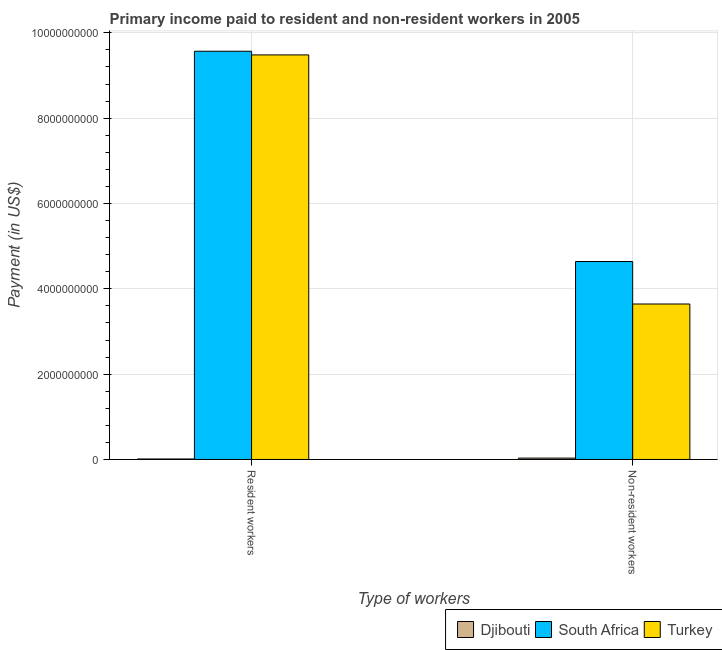How many different coloured bars are there?
Make the answer very short. 3. How many groups of bars are there?
Your answer should be very brief. 2. Are the number of bars per tick equal to the number of legend labels?
Ensure brevity in your answer.  Yes. Are the number of bars on each tick of the X-axis equal?
Make the answer very short. Yes. How many bars are there on the 2nd tick from the right?
Make the answer very short. 3. What is the label of the 1st group of bars from the left?
Offer a very short reply. Resident workers. What is the payment made to non-resident workers in Turkey?
Offer a very short reply. 3.64e+09. Across all countries, what is the maximum payment made to resident workers?
Offer a terse response. 9.57e+09. Across all countries, what is the minimum payment made to non-resident workers?
Ensure brevity in your answer.  3.20e+07. In which country was the payment made to resident workers maximum?
Your answer should be very brief. South Africa. In which country was the payment made to resident workers minimum?
Give a very brief answer. Djibouti. What is the total payment made to non-resident workers in the graph?
Provide a succinct answer. 8.32e+09. What is the difference between the payment made to resident workers in South Africa and that in Turkey?
Make the answer very short. 8.63e+07. What is the difference between the payment made to resident workers in Djibouti and the payment made to non-resident workers in South Africa?
Offer a very short reply. -4.63e+09. What is the average payment made to non-resident workers per country?
Offer a very short reply. 2.77e+09. What is the difference between the payment made to non-resident workers and payment made to resident workers in Djibouti?
Your answer should be compact. 2.08e+07. What is the ratio of the payment made to resident workers in South Africa to that in Djibouti?
Offer a very short reply. 857.19. What does the 2nd bar from the left in Non-resident workers represents?
Offer a terse response. South Africa. What does the 3rd bar from the right in Non-resident workers represents?
Your response must be concise. Djibouti. How many bars are there?
Keep it short and to the point. 6. How many countries are there in the graph?
Offer a terse response. 3. How many legend labels are there?
Your response must be concise. 3. What is the title of the graph?
Ensure brevity in your answer.  Primary income paid to resident and non-resident workers in 2005. Does "American Samoa" appear as one of the legend labels in the graph?
Ensure brevity in your answer.  No. What is the label or title of the X-axis?
Offer a terse response. Type of workers. What is the label or title of the Y-axis?
Keep it short and to the point. Payment (in US$). What is the Payment (in US$) of Djibouti in Resident workers?
Give a very brief answer. 1.12e+07. What is the Payment (in US$) of South Africa in Resident workers?
Offer a terse response. 9.57e+09. What is the Payment (in US$) in Turkey in Resident workers?
Provide a succinct answer. 9.48e+09. What is the Payment (in US$) in Djibouti in Non-resident workers?
Make the answer very short. 3.20e+07. What is the Payment (in US$) of South Africa in Non-resident workers?
Provide a short and direct response. 4.64e+09. What is the Payment (in US$) in Turkey in Non-resident workers?
Offer a terse response. 3.64e+09. Across all Type of workers, what is the maximum Payment (in US$) of Djibouti?
Offer a very short reply. 3.20e+07. Across all Type of workers, what is the maximum Payment (in US$) of South Africa?
Offer a terse response. 9.57e+09. Across all Type of workers, what is the maximum Payment (in US$) of Turkey?
Your response must be concise. 9.48e+09. Across all Type of workers, what is the minimum Payment (in US$) of Djibouti?
Offer a terse response. 1.12e+07. Across all Type of workers, what is the minimum Payment (in US$) in South Africa?
Your answer should be very brief. 4.64e+09. Across all Type of workers, what is the minimum Payment (in US$) in Turkey?
Your answer should be compact. 3.64e+09. What is the total Payment (in US$) of Djibouti in the graph?
Your response must be concise. 4.31e+07. What is the total Payment (in US$) in South Africa in the graph?
Offer a very short reply. 1.42e+1. What is the total Payment (in US$) in Turkey in the graph?
Your answer should be compact. 1.31e+1. What is the difference between the Payment (in US$) of Djibouti in Resident workers and that in Non-resident workers?
Offer a very short reply. -2.08e+07. What is the difference between the Payment (in US$) of South Africa in Resident workers and that in Non-resident workers?
Give a very brief answer. 4.93e+09. What is the difference between the Payment (in US$) of Turkey in Resident workers and that in Non-resident workers?
Ensure brevity in your answer.  5.84e+09. What is the difference between the Payment (in US$) of Djibouti in Resident workers and the Payment (in US$) of South Africa in Non-resident workers?
Keep it short and to the point. -4.63e+09. What is the difference between the Payment (in US$) in Djibouti in Resident workers and the Payment (in US$) in Turkey in Non-resident workers?
Provide a succinct answer. -3.63e+09. What is the difference between the Payment (in US$) in South Africa in Resident workers and the Payment (in US$) in Turkey in Non-resident workers?
Your answer should be compact. 5.93e+09. What is the average Payment (in US$) of Djibouti per Type of workers?
Offer a terse response. 2.16e+07. What is the average Payment (in US$) in South Africa per Type of workers?
Keep it short and to the point. 7.10e+09. What is the average Payment (in US$) of Turkey per Type of workers?
Provide a short and direct response. 6.56e+09. What is the difference between the Payment (in US$) of Djibouti and Payment (in US$) of South Africa in Resident workers?
Offer a terse response. -9.56e+09. What is the difference between the Payment (in US$) of Djibouti and Payment (in US$) of Turkey in Resident workers?
Offer a very short reply. -9.47e+09. What is the difference between the Payment (in US$) in South Africa and Payment (in US$) in Turkey in Resident workers?
Provide a succinct answer. 8.63e+07. What is the difference between the Payment (in US$) of Djibouti and Payment (in US$) of South Africa in Non-resident workers?
Your answer should be compact. -4.61e+09. What is the difference between the Payment (in US$) of Djibouti and Payment (in US$) of Turkey in Non-resident workers?
Your answer should be very brief. -3.61e+09. What is the difference between the Payment (in US$) in South Africa and Payment (in US$) in Turkey in Non-resident workers?
Keep it short and to the point. 9.96e+08. What is the ratio of the Payment (in US$) of Djibouti in Resident workers to that in Non-resident workers?
Your response must be concise. 0.35. What is the ratio of the Payment (in US$) of South Africa in Resident workers to that in Non-resident workers?
Your answer should be very brief. 2.06. What is the ratio of the Payment (in US$) in Turkey in Resident workers to that in Non-resident workers?
Offer a very short reply. 2.6. What is the difference between the highest and the second highest Payment (in US$) in Djibouti?
Keep it short and to the point. 2.08e+07. What is the difference between the highest and the second highest Payment (in US$) in South Africa?
Ensure brevity in your answer.  4.93e+09. What is the difference between the highest and the second highest Payment (in US$) of Turkey?
Keep it short and to the point. 5.84e+09. What is the difference between the highest and the lowest Payment (in US$) of Djibouti?
Keep it short and to the point. 2.08e+07. What is the difference between the highest and the lowest Payment (in US$) in South Africa?
Your answer should be compact. 4.93e+09. What is the difference between the highest and the lowest Payment (in US$) in Turkey?
Ensure brevity in your answer.  5.84e+09. 